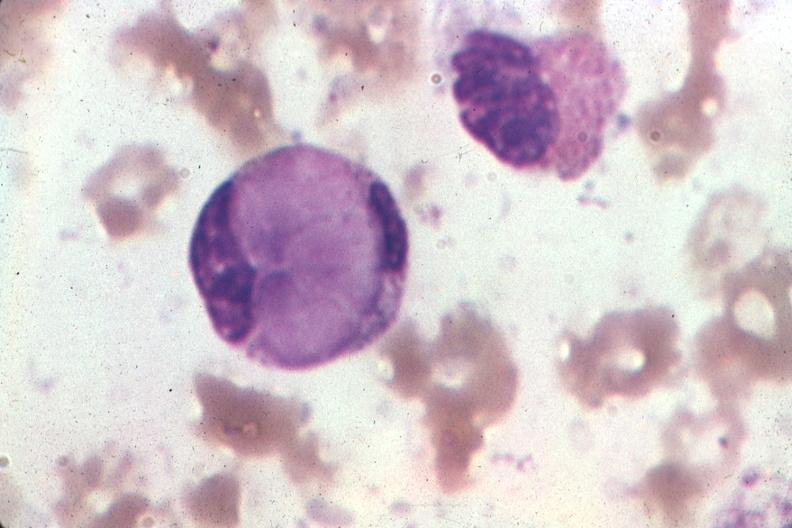does this show wrights very good example?
Answer the question using a single word or phrase. No 